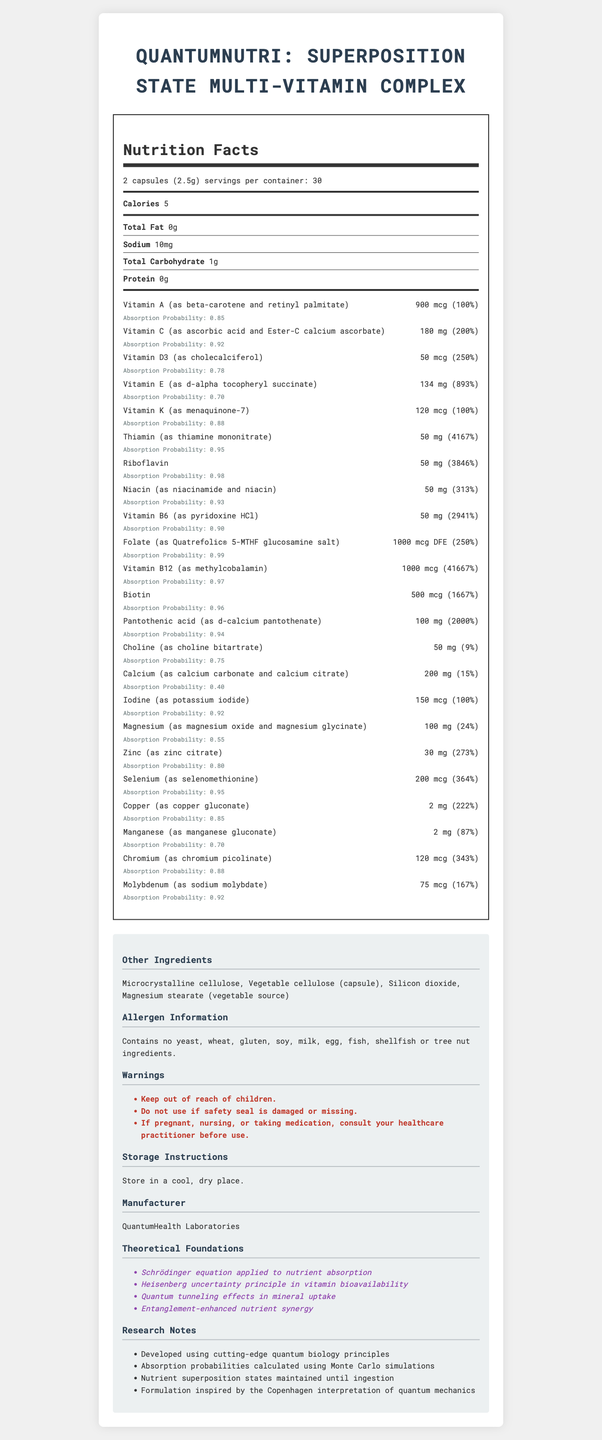what is the serving size of QuantumNutri? The serving size is clearly indicated as "2 capsules (2.5g)".
Answer: 2 capsules (2.5g) how many calories are there per serving? The document states that there are 5 calories per serving.
Answer: 5 what is the absorption probability for Vitamin A? The absorption probability for Vitamin A is listed as 0.85.
Answer: 0.85 name one of the warnings associated with QuantumNutri? One of the warnings is "Keep out of reach of children."
Answer: Keep out of reach of children. what is the daily value percentage of Vitamin B12? The document lists the daily value percentage of Vitamin B12 as 41667%.
Answer: 41667% which vitamin has the highest daily value percentage? A. Vitamin C B. Thiamin C. Vitamin B12 D. Biotin Vitamin B12 has the highest daily value percentage at 41667%.
Answer: C what is the absorption probability range for all the vitamins and minerals listed? A. 0.40 - 0.98 B. 0.55 - 0.99 C. 0.60 - 0.93 D. 0.45 - 0.88 The absorption probabilities ranges from 0.40 for Calcium to 0.98 for Riboflavin.
Answer: A are there any fish ingredients in QuantumNutri? The document specifies: "Contains no yeast, wheat, gluten, soy, milk, egg, fish, shellfish or tree nut ingredients."
Answer: No does QuantumNutri contain magnesium stearate? One of the other ingredients listed is "Magnesium stearate (vegetable source)".
Answer: Yes what are the main theoretical foundations of QuantumNutri? The document lists these theoretical foundations.
Answer: Schrödinger equation applied to nutrient absorption, Heisenberg uncertainty principle in vitamin bioavailability, Quantum tunneling effects in mineral uptake, Entanglement-enhanced nutrient synergy can you store QuantumNutri in a humid place? The storage instructions state to "Store in a cool, dry place."
Answer: No what entity manufactured QuantumNutri? The manufacturer is stated as QuantumHealth Laboratories.
Answer: QuantumHealth Laboratories summarize the key aspects of this document The document thoroughly details the nutritional content of QuantumNutri along with additional information to ensure user safety and product efficacy based on quantum biology principles.
Answer: The document provides detailed Nutritional Facts for "QuantumNutri: Superposition State Multi-Vitamin Complex", including serving size, calorie count, fat content, and a comprehensive list of vitamins and minerals along with their respective amounts, daily values, and absorption probabilities. It also includes information about other ingredients, allergen information, warnings, storage instructions, the manufacturer, theoretical foundations, and research notes. based on the date of testing, does the product still have a valid expiration date? The document provided does not include any dates related to testing or expiration. Without those dates, it is not possible to determine if the product is still valid.
Answer: Not enough information 